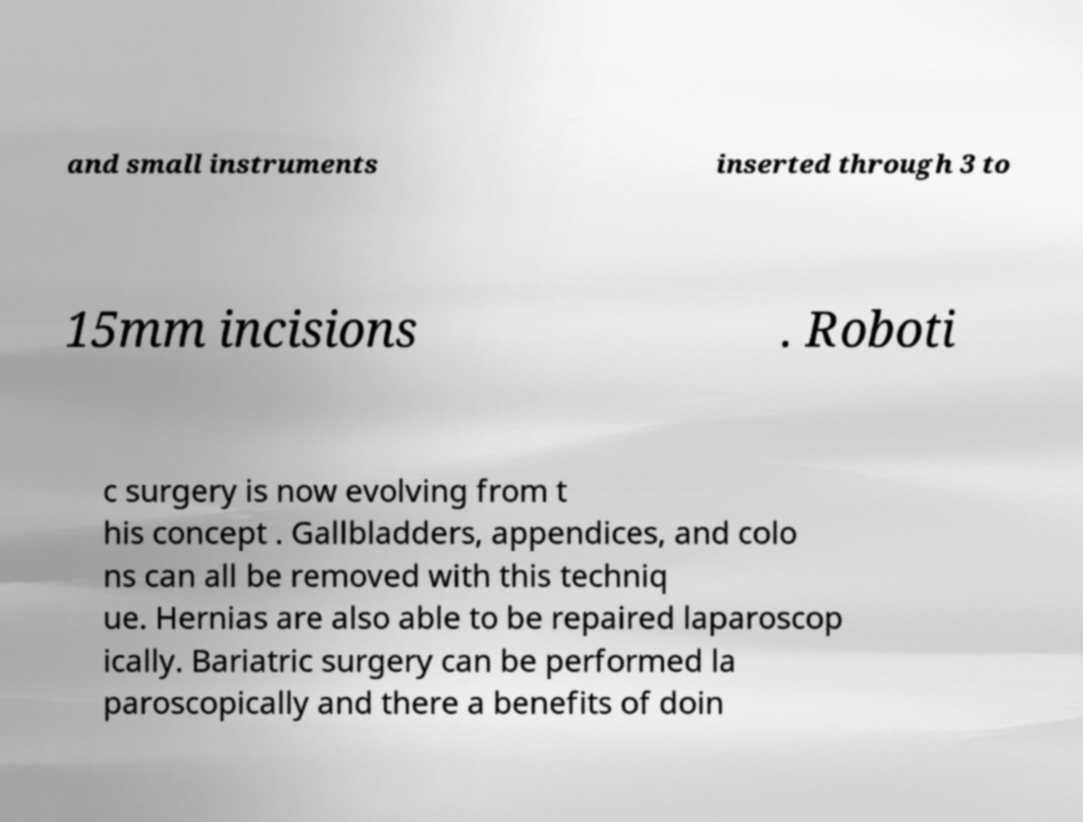Please read and relay the text visible in this image. What does it say? and small instruments inserted through 3 to 15mm incisions . Roboti c surgery is now evolving from t his concept . Gallbladders, appendices, and colo ns can all be removed with this techniq ue. Hernias are also able to be repaired laparoscop ically. Bariatric surgery can be performed la paroscopically and there a benefits of doin 